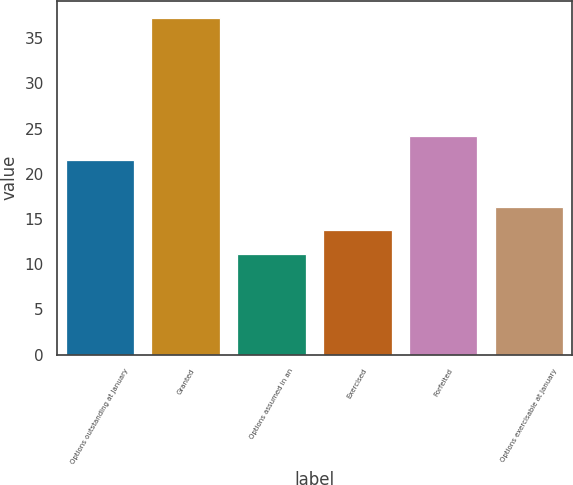Convert chart to OTSL. <chart><loc_0><loc_0><loc_500><loc_500><bar_chart><fcel>Options outstanding at January<fcel>Granted<fcel>Options assumed in an<fcel>Exercised<fcel>Forfeited<fcel>Options exercisable at January<nl><fcel>21.58<fcel>37.27<fcel>11.14<fcel>13.75<fcel>24.19<fcel>16.36<nl></chart> 